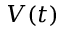<formula> <loc_0><loc_0><loc_500><loc_500>V ( t )</formula> 